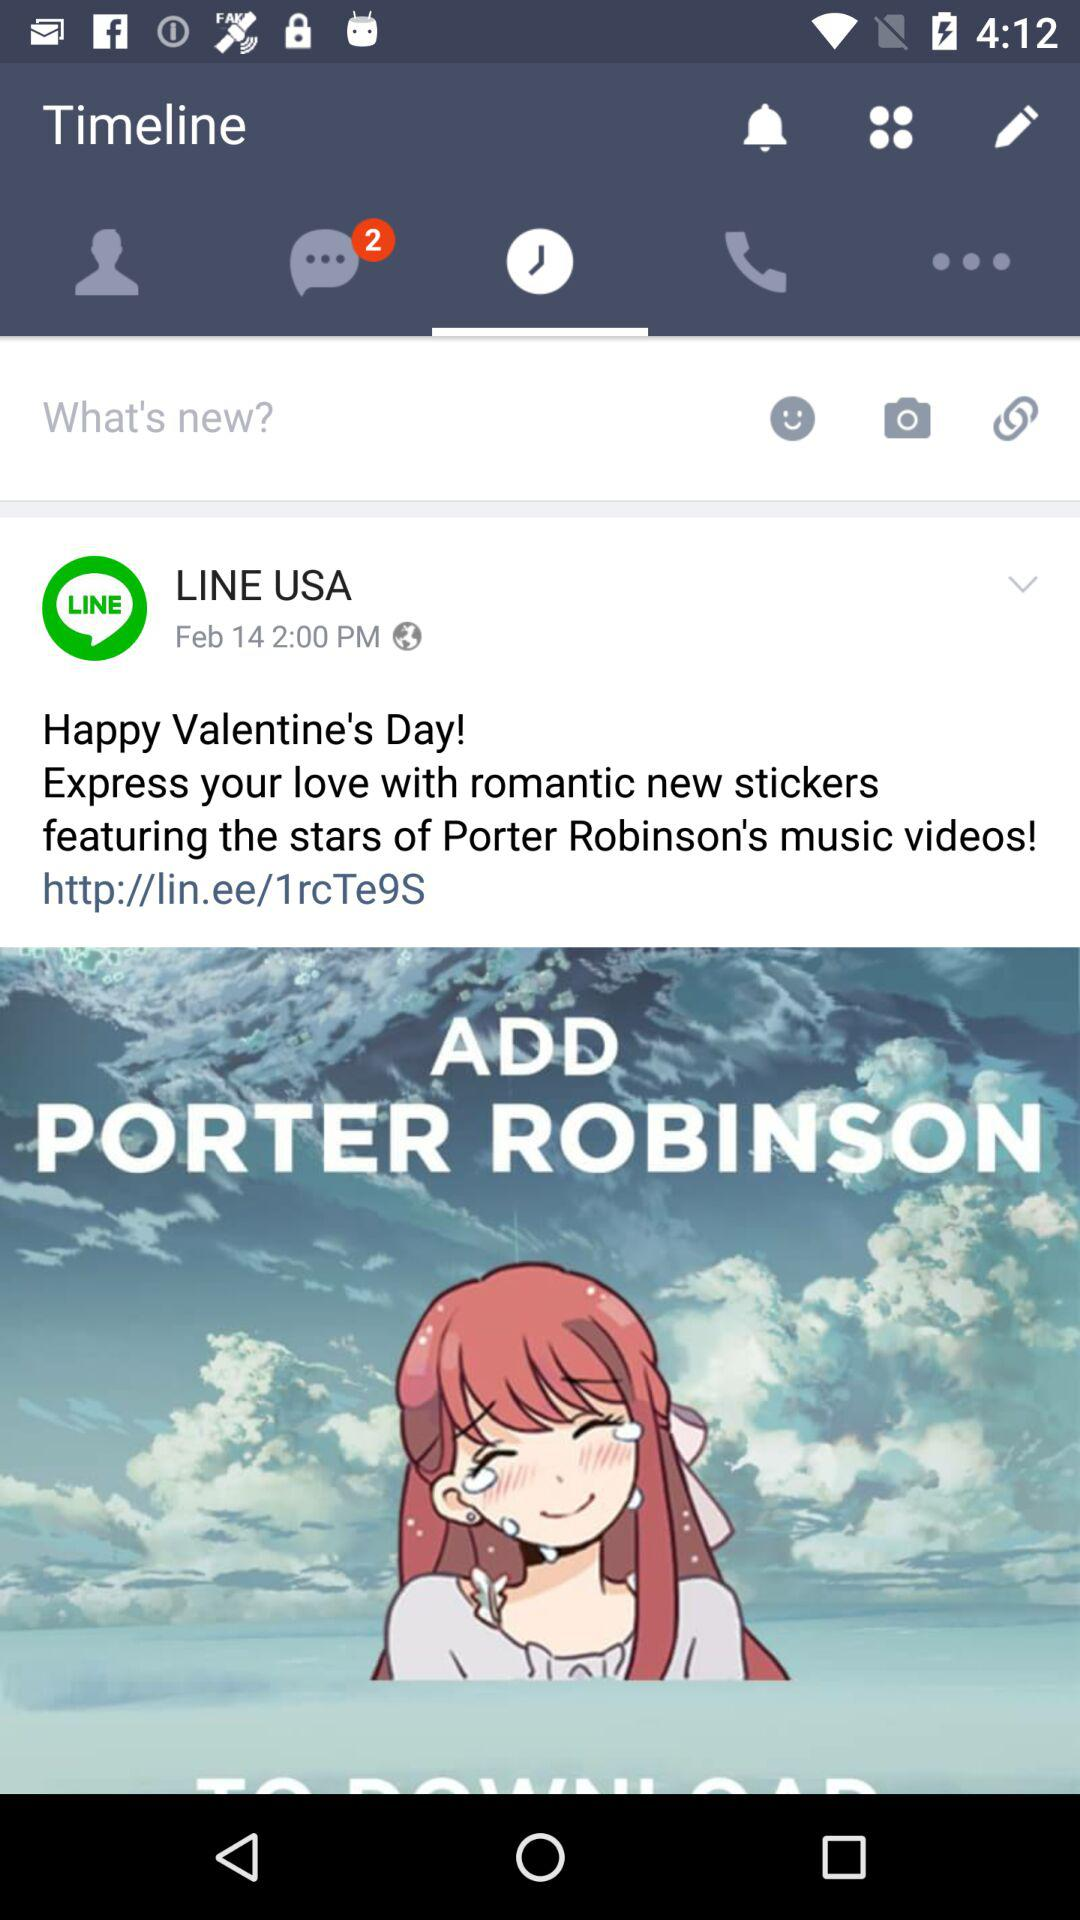How many comments are on the post?
When the provided information is insufficient, respond with <no answer>. <no answer> 